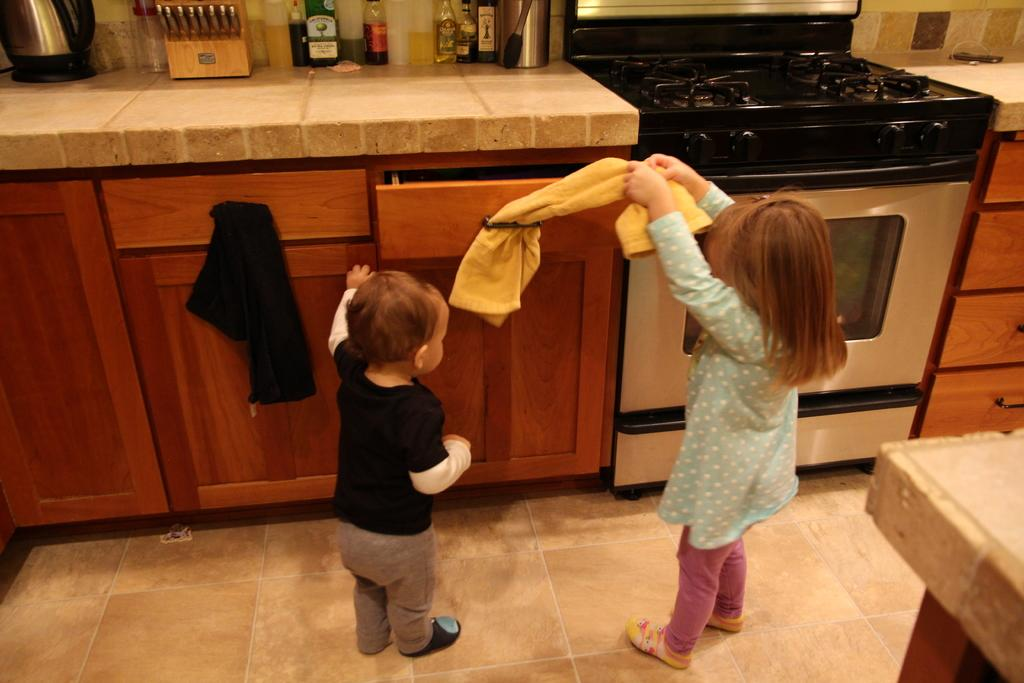How many kids are in the image? There are two kids in the image. What is located on the platform in the image? There are objects on the platform in the image. What type of appliance can be seen in the image? There is a stove in the image. What part of the room is visible at the bottom of the image? The floor is visible at the bottom of the image. What type of note is being passed between the kids in the image? There is no note being passed between the kids in the image. 